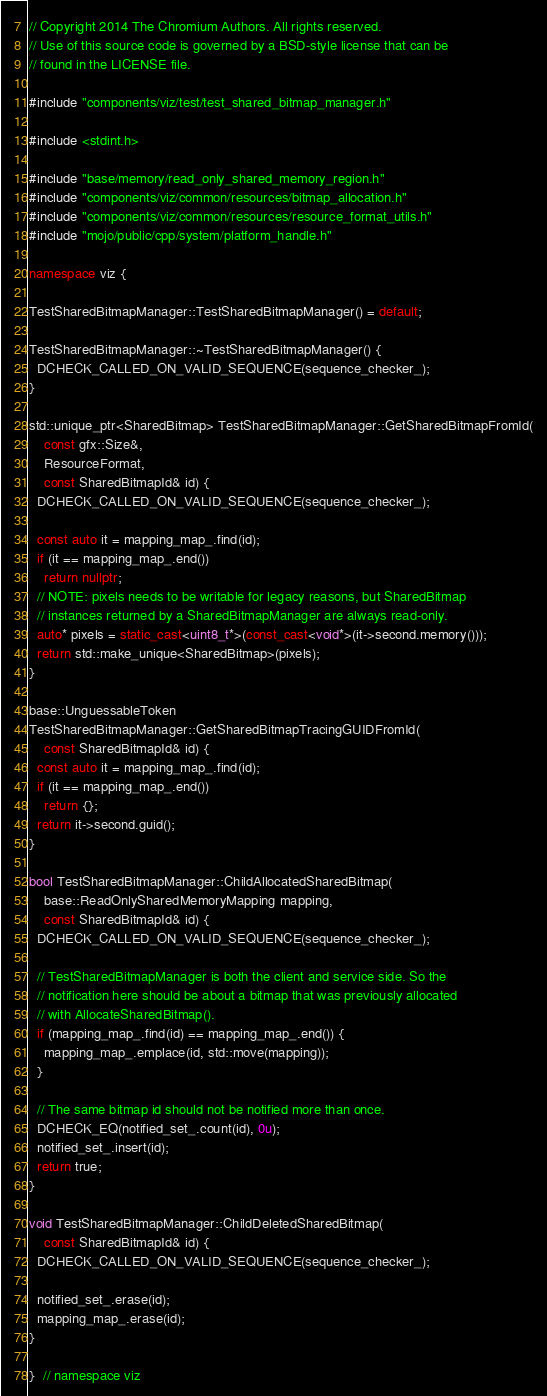Convert code to text. <code><loc_0><loc_0><loc_500><loc_500><_C++_>// Copyright 2014 The Chromium Authors. All rights reserved.
// Use of this source code is governed by a BSD-style license that can be
// found in the LICENSE file.

#include "components/viz/test/test_shared_bitmap_manager.h"

#include <stdint.h>

#include "base/memory/read_only_shared_memory_region.h"
#include "components/viz/common/resources/bitmap_allocation.h"
#include "components/viz/common/resources/resource_format_utils.h"
#include "mojo/public/cpp/system/platform_handle.h"

namespace viz {

TestSharedBitmapManager::TestSharedBitmapManager() = default;

TestSharedBitmapManager::~TestSharedBitmapManager() {
  DCHECK_CALLED_ON_VALID_SEQUENCE(sequence_checker_);
}

std::unique_ptr<SharedBitmap> TestSharedBitmapManager::GetSharedBitmapFromId(
    const gfx::Size&,
    ResourceFormat,
    const SharedBitmapId& id) {
  DCHECK_CALLED_ON_VALID_SEQUENCE(sequence_checker_);

  const auto it = mapping_map_.find(id);
  if (it == mapping_map_.end())
    return nullptr;
  // NOTE: pixels needs to be writable for legacy reasons, but SharedBitmap
  // instances returned by a SharedBitmapManager are always read-only.
  auto* pixels = static_cast<uint8_t*>(const_cast<void*>(it->second.memory()));
  return std::make_unique<SharedBitmap>(pixels);
}

base::UnguessableToken
TestSharedBitmapManager::GetSharedBitmapTracingGUIDFromId(
    const SharedBitmapId& id) {
  const auto it = mapping_map_.find(id);
  if (it == mapping_map_.end())
    return {};
  return it->second.guid();
}

bool TestSharedBitmapManager::ChildAllocatedSharedBitmap(
    base::ReadOnlySharedMemoryMapping mapping,
    const SharedBitmapId& id) {
  DCHECK_CALLED_ON_VALID_SEQUENCE(sequence_checker_);

  // TestSharedBitmapManager is both the client and service side. So the
  // notification here should be about a bitmap that was previously allocated
  // with AllocateSharedBitmap().
  if (mapping_map_.find(id) == mapping_map_.end()) {
    mapping_map_.emplace(id, std::move(mapping));
  }

  // The same bitmap id should not be notified more than once.
  DCHECK_EQ(notified_set_.count(id), 0u);
  notified_set_.insert(id);
  return true;
}

void TestSharedBitmapManager::ChildDeletedSharedBitmap(
    const SharedBitmapId& id) {
  DCHECK_CALLED_ON_VALID_SEQUENCE(sequence_checker_);

  notified_set_.erase(id);
  mapping_map_.erase(id);
}

}  // namespace viz
</code> 